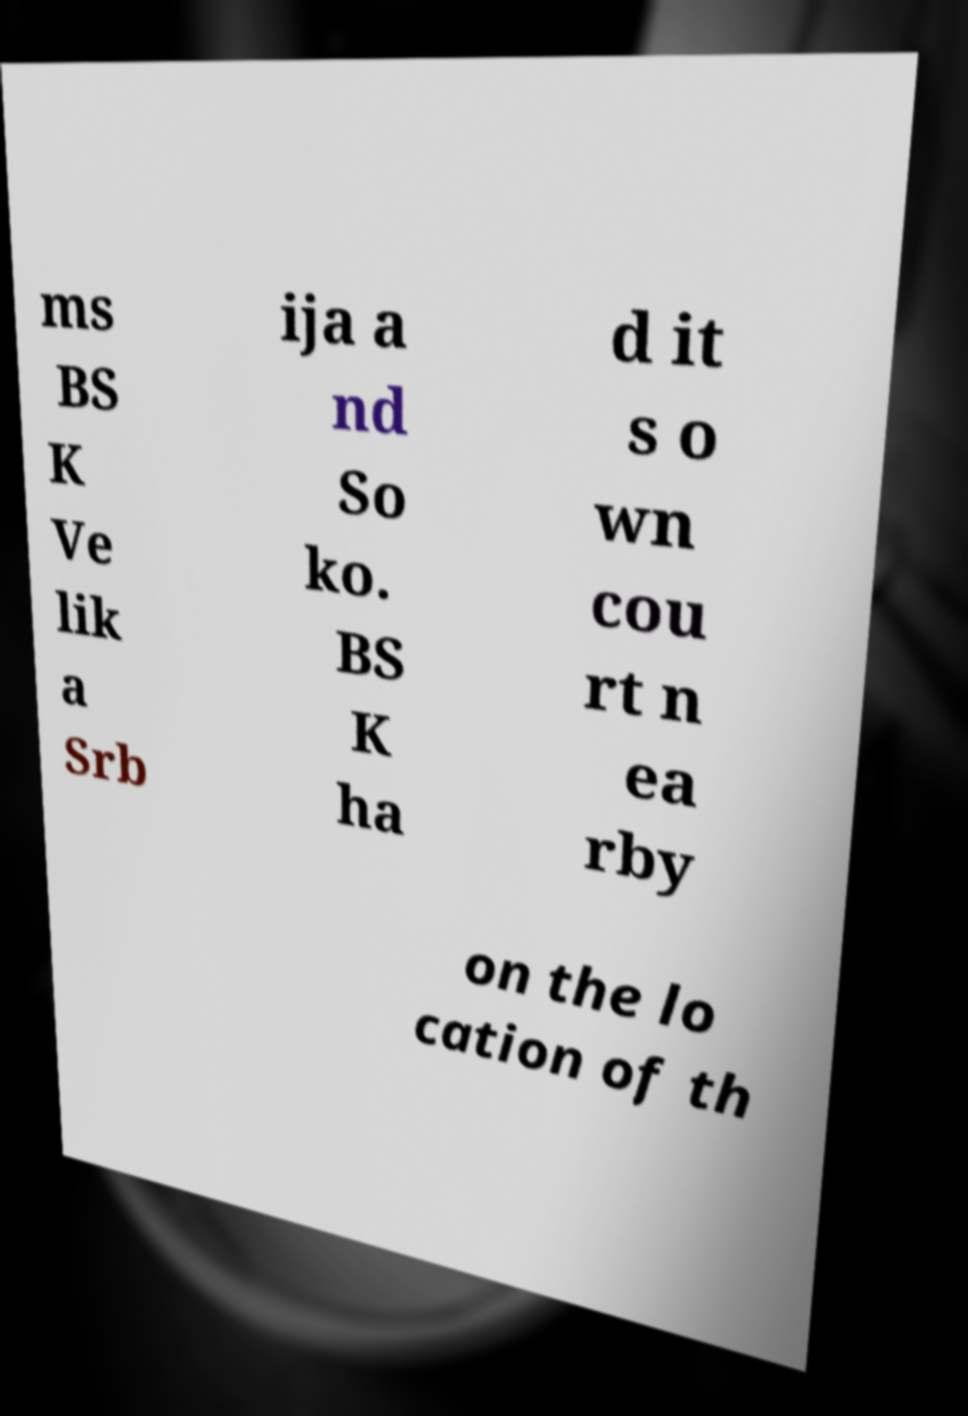Please read and relay the text visible in this image. What does it say? ms BS K Ve lik a Srb ija a nd So ko. BS K ha d it s o wn cou rt n ea rby on the lo cation of th 